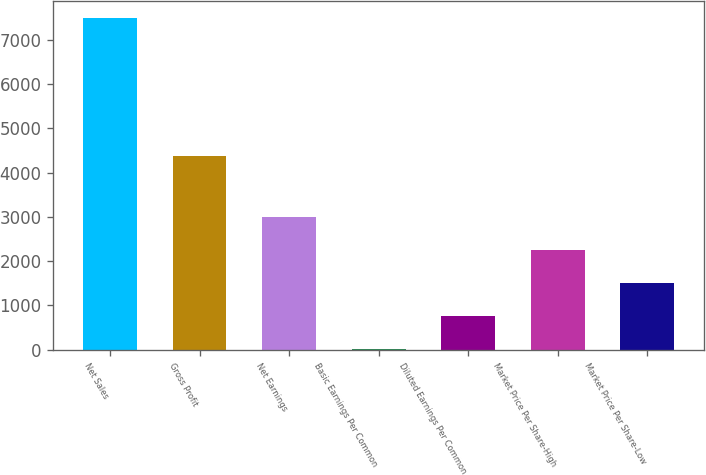<chart> <loc_0><loc_0><loc_500><loc_500><bar_chart><fcel>Net Sales<fcel>Gross Profit<fcel>Net Earnings<fcel>Basic Earnings Per Common<fcel>Diluted Earnings Per Common<fcel>Market Price Per Share-High<fcel>Market Price Per Share-Low<nl><fcel>7494.9<fcel>4365.9<fcel>2998.47<fcel>0.83<fcel>750.24<fcel>2249.06<fcel>1499.65<nl></chart> 